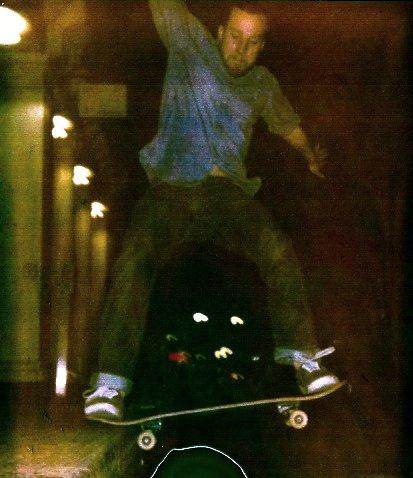Is the man wearing a button up shirt?
Write a very short answer. Yes. What is the man doing?
Quick response, please. Skateboarding. Does this person have good balance?
Be succinct. Yes. 